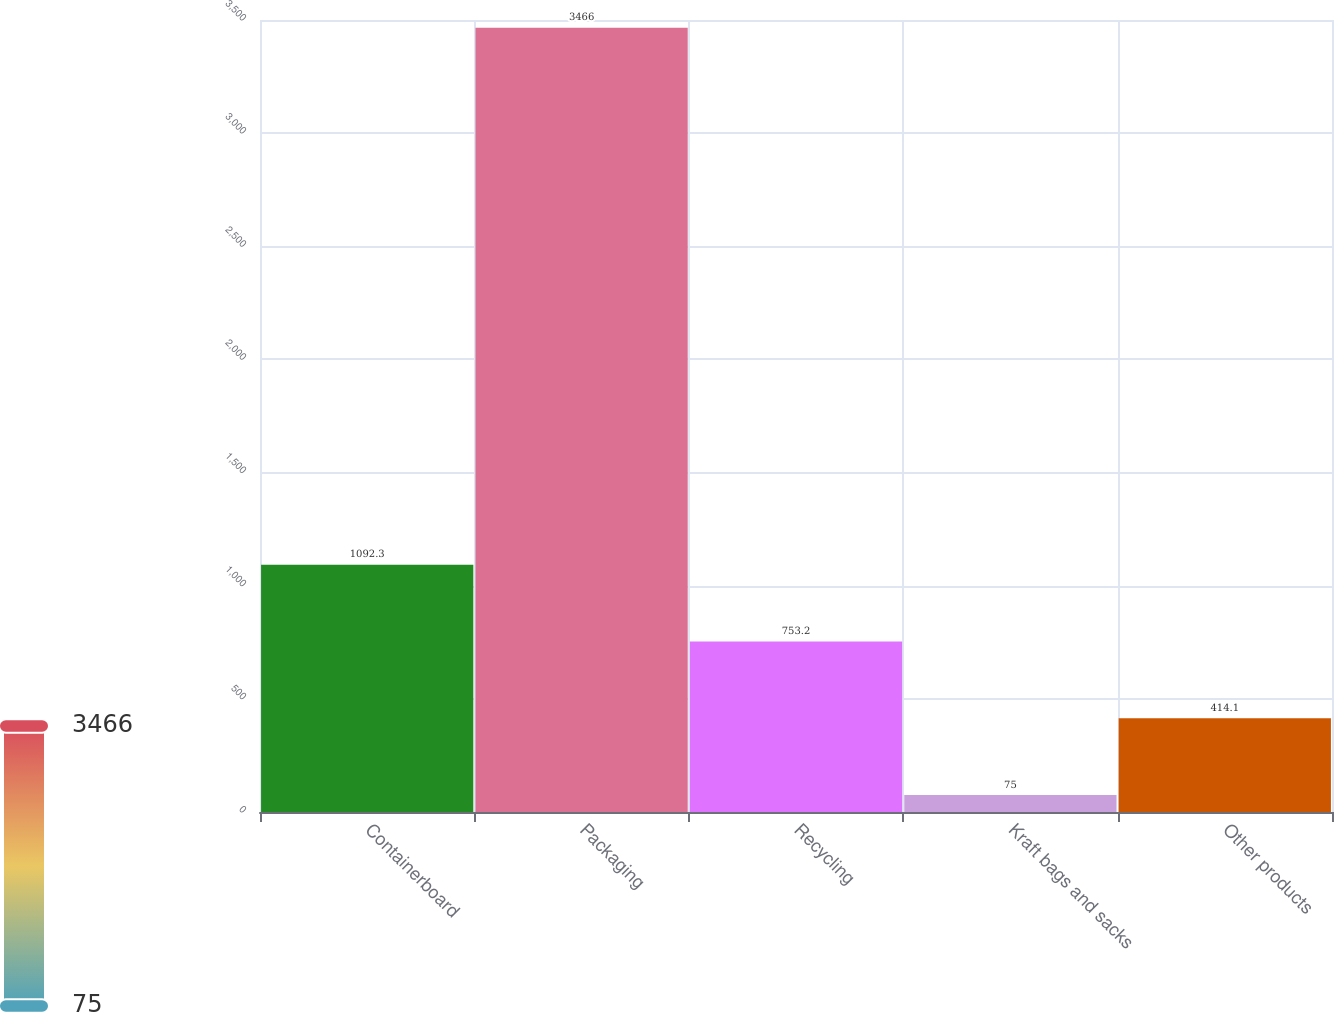Convert chart to OTSL. <chart><loc_0><loc_0><loc_500><loc_500><bar_chart><fcel>Containerboard<fcel>Packaging<fcel>Recycling<fcel>Kraft bags and sacks<fcel>Other products<nl><fcel>1092.3<fcel>3466<fcel>753.2<fcel>75<fcel>414.1<nl></chart> 